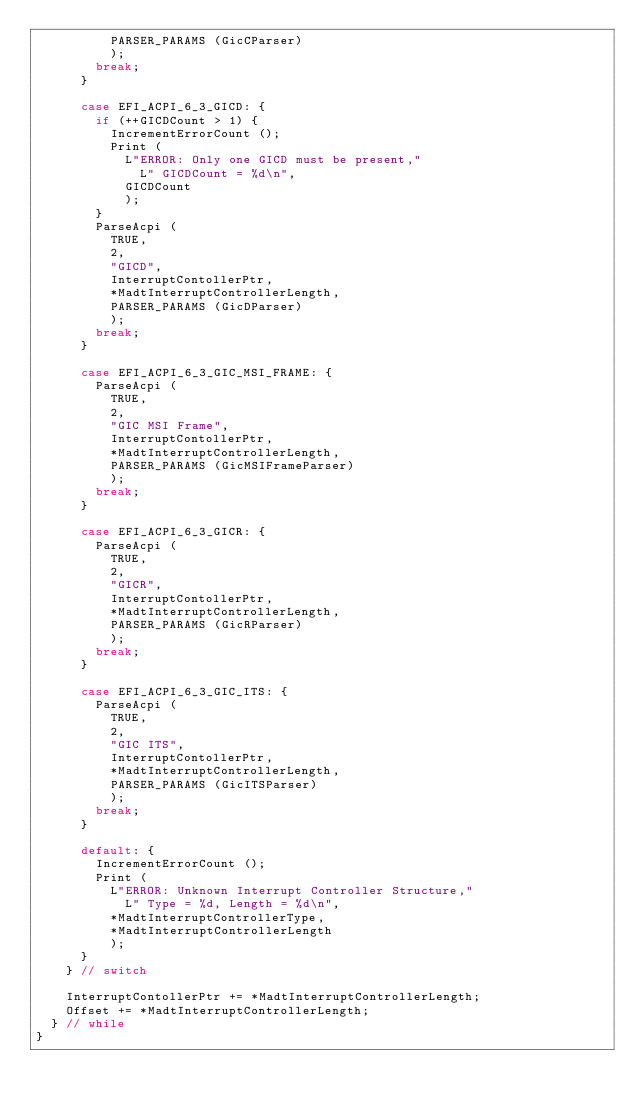<code> <loc_0><loc_0><loc_500><loc_500><_C_>          PARSER_PARAMS (GicCParser)
          );
        break;
      }

      case EFI_ACPI_6_3_GICD: {
        if (++GICDCount > 1) {
          IncrementErrorCount ();
          Print (
            L"ERROR: Only one GICD must be present,"
              L" GICDCount = %d\n",
            GICDCount
            );
        }
        ParseAcpi (
          TRUE,
          2,
          "GICD",
          InterruptContollerPtr,
          *MadtInterruptControllerLength,
          PARSER_PARAMS (GicDParser)
          );
        break;
      }

      case EFI_ACPI_6_3_GIC_MSI_FRAME: {
        ParseAcpi (
          TRUE,
          2,
          "GIC MSI Frame",
          InterruptContollerPtr,
          *MadtInterruptControllerLength,
          PARSER_PARAMS (GicMSIFrameParser)
          );
        break;
      }

      case EFI_ACPI_6_3_GICR: {
        ParseAcpi (
          TRUE,
          2,
          "GICR",
          InterruptContollerPtr,
          *MadtInterruptControllerLength,
          PARSER_PARAMS (GicRParser)
          );
        break;
      }

      case EFI_ACPI_6_3_GIC_ITS: {
        ParseAcpi (
          TRUE,
          2,
          "GIC ITS",
          InterruptContollerPtr,
          *MadtInterruptControllerLength,
          PARSER_PARAMS (GicITSParser)
          );
        break;
      }

      default: {
        IncrementErrorCount ();
        Print (
          L"ERROR: Unknown Interrupt Controller Structure,"
            L" Type = %d, Length = %d\n",
          *MadtInterruptControllerType,
          *MadtInterruptControllerLength
          );
      }
    } // switch

    InterruptContollerPtr += *MadtInterruptControllerLength;
    Offset += *MadtInterruptControllerLength;
  } // while
}
</code> 